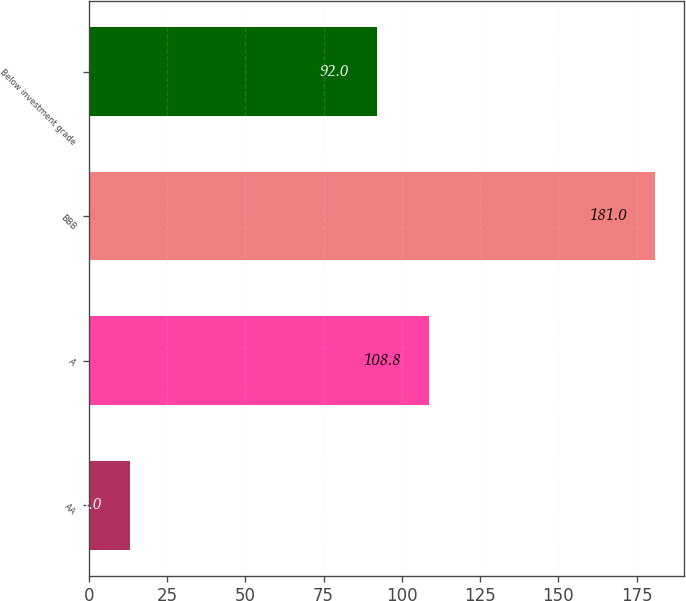Convert chart to OTSL. <chart><loc_0><loc_0><loc_500><loc_500><bar_chart><fcel>AA<fcel>A<fcel>BBB<fcel>Below investment grade<nl><fcel>13<fcel>108.8<fcel>181<fcel>92<nl></chart> 